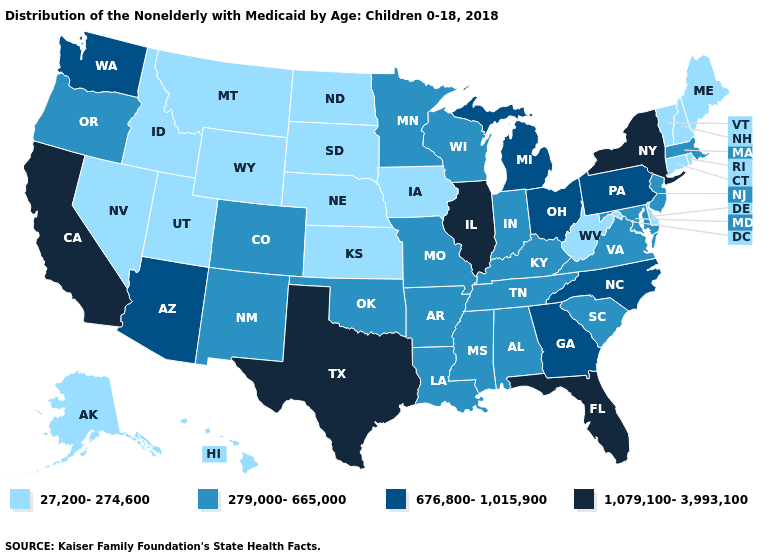What is the value of Montana?
Write a very short answer. 27,200-274,600. Does Florida have the same value as Texas?
Keep it brief. Yes. What is the value of Virginia?
Write a very short answer. 279,000-665,000. Name the states that have a value in the range 676,800-1,015,900?
Be succinct. Arizona, Georgia, Michigan, North Carolina, Ohio, Pennsylvania, Washington. What is the value of West Virginia?
Short answer required. 27,200-274,600. Which states have the highest value in the USA?
Concise answer only. California, Florida, Illinois, New York, Texas. Name the states that have a value in the range 1,079,100-3,993,100?
Give a very brief answer. California, Florida, Illinois, New York, Texas. Name the states that have a value in the range 676,800-1,015,900?
Short answer required. Arizona, Georgia, Michigan, North Carolina, Ohio, Pennsylvania, Washington. Name the states that have a value in the range 27,200-274,600?
Be succinct. Alaska, Connecticut, Delaware, Hawaii, Idaho, Iowa, Kansas, Maine, Montana, Nebraska, Nevada, New Hampshire, North Dakota, Rhode Island, South Dakota, Utah, Vermont, West Virginia, Wyoming. Which states have the highest value in the USA?
Short answer required. California, Florida, Illinois, New York, Texas. Does New Mexico have the same value as Oregon?
Be succinct. Yes. What is the value of South Dakota?
Answer briefly. 27,200-274,600. Does Alaska have the lowest value in the USA?
Answer briefly. Yes. Name the states that have a value in the range 27,200-274,600?
Be succinct. Alaska, Connecticut, Delaware, Hawaii, Idaho, Iowa, Kansas, Maine, Montana, Nebraska, Nevada, New Hampshire, North Dakota, Rhode Island, South Dakota, Utah, Vermont, West Virginia, Wyoming. Which states have the lowest value in the West?
Short answer required. Alaska, Hawaii, Idaho, Montana, Nevada, Utah, Wyoming. 